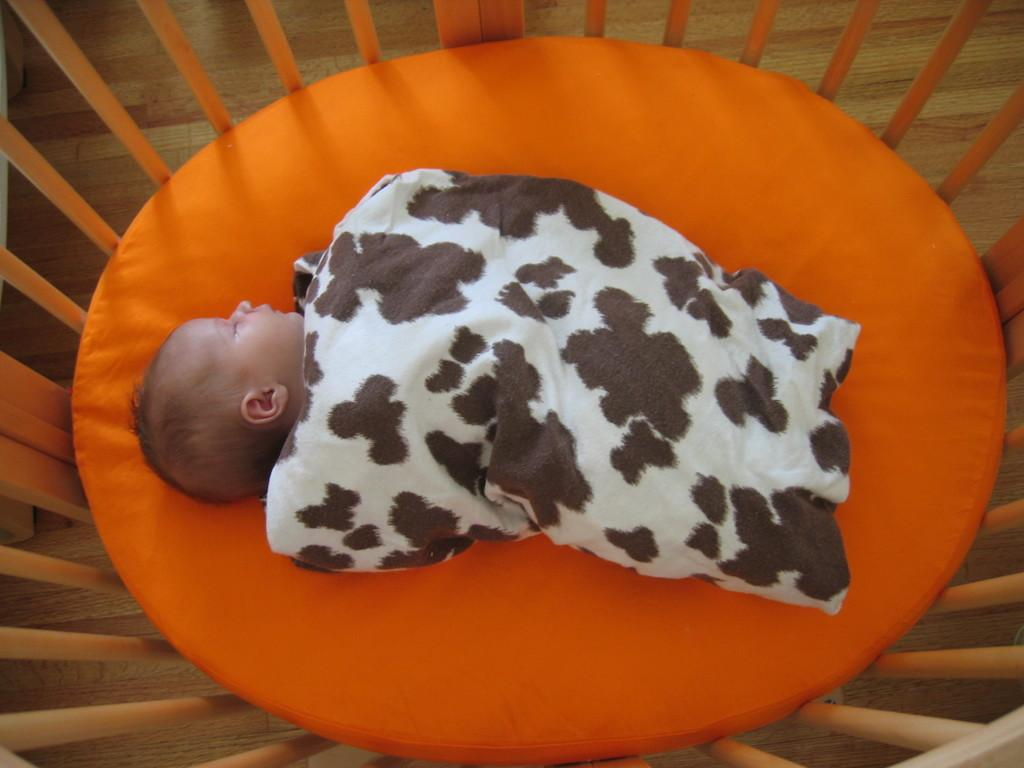What is the main subject of the image? There is a baby in the image. Where is the baby located? The baby is lying on a bed. What is covering the baby? There is a blanket on the baby. What type of barrier surrounds the bed? There is a wooden boundary around the bed. What type of flooring is present in the room? The floor is wooden and furnished. What type of shirt is the baby wearing in the image? The image does not show the baby wearing a shirt; it only shows the baby lying on a bed with a blanket. 